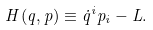Convert formula to latex. <formula><loc_0><loc_0><loc_500><loc_500>H ( q , p ) \equiv \dot { q } ^ { i } p _ { i } - L .</formula> 